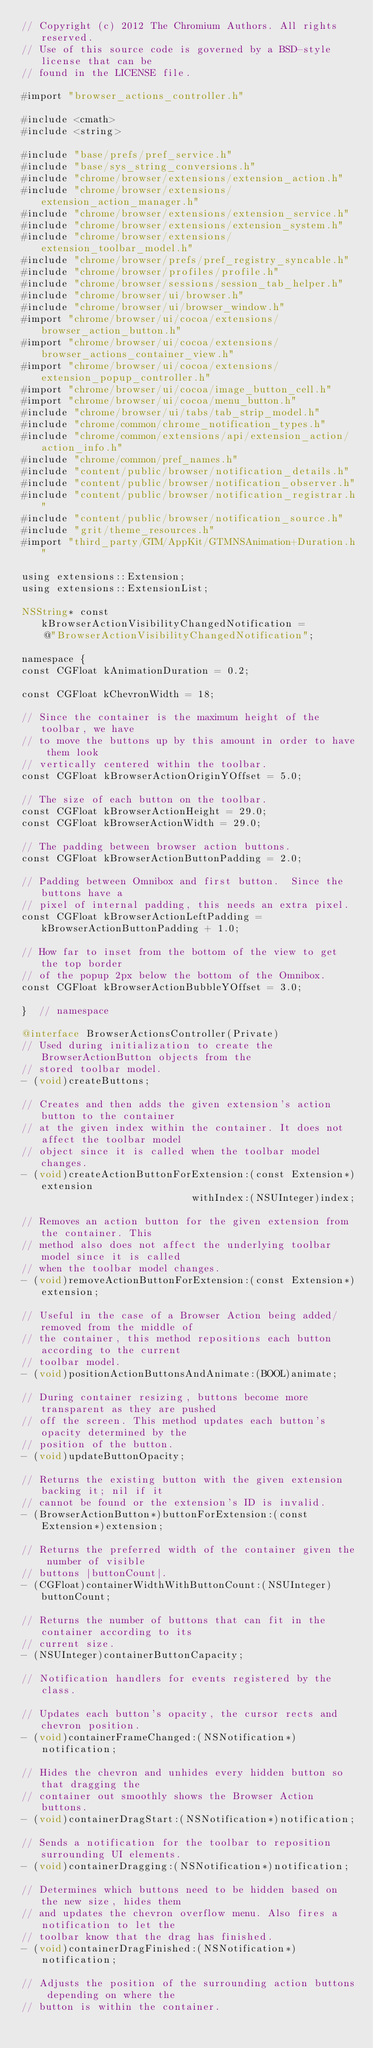<code> <loc_0><loc_0><loc_500><loc_500><_ObjectiveC_>// Copyright (c) 2012 The Chromium Authors. All rights reserved.
// Use of this source code is governed by a BSD-style license that can be
// found in the LICENSE file.

#import "browser_actions_controller.h"

#include <cmath>
#include <string>

#include "base/prefs/pref_service.h"
#include "base/sys_string_conversions.h"
#include "chrome/browser/extensions/extension_action.h"
#include "chrome/browser/extensions/extension_action_manager.h"
#include "chrome/browser/extensions/extension_service.h"
#include "chrome/browser/extensions/extension_system.h"
#include "chrome/browser/extensions/extension_toolbar_model.h"
#include "chrome/browser/prefs/pref_registry_syncable.h"
#include "chrome/browser/profiles/profile.h"
#include "chrome/browser/sessions/session_tab_helper.h"
#include "chrome/browser/ui/browser.h"
#include "chrome/browser/ui/browser_window.h"
#import "chrome/browser/ui/cocoa/extensions/browser_action_button.h"
#import "chrome/browser/ui/cocoa/extensions/browser_actions_container_view.h"
#import "chrome/browser/ui/cocoa/extensions/extension_popup_controller.h"
#import "chrome/browser/ui/cocoa/image_button_cell.h"
#import "chrome/browser/ui/cocoa/menu_button.h"
#include "chrome/browser/ui/tabs/tab_strip_model.h"
#include "chrome/common/chrome_notification_types.h"
#include "chrome/common/extensions/api/extension_action/action_info.h"
#include "chrome/common/pref_names.h"
#include "content/public/browser/notification_details.h"
#include "content/public/browser/notification_observer.h"
#include "content/public/browser/notification_registrar.h"
#include "content/public/browser/notification_source.h"
#include "grit/theme_resources.h"
#import "third_party/GTM/AppKit/GTMNSAnimation+Duration.h"

using extensions::Extension;
using extensions::ExtensionList;

NSString* const kBrowserActionVisibilityChangedNotification =
    @"BrowserActionVisibilityChangedNotification";

namespace {
const CGFloat kAnimationDuration = 0.2;

const CGFloat kChevronWidth = 18;

// Since the container is the maximum height of the toolbar, we have
// to move the buttons up by this amount in order to have them look
// vertically centered within the toolbar.
const CGFloat kBrowserActionOriginYOffset = 5.0;

// The size of each button on the toolbar.
const CGFloat kBrowserActionHeight = 29.0;
const CGFloat kBrowserActionWidth = 29.0;

// The padding between browser action buttons.
const CGFloat kBrowserActionButtonPadding = 2.0;

// Padding between Omnibox and first button.  Since the buttons have a
// pixel of internal padding, this needs an extra pixel.
const CGFloat kBrowserActionLeftPadding = kBrowserActionButtonPadding + 1.0;

// How far to inset from the bottom of the view to get the top border
// of the popup 2px below the bottom of the Omnibox.
const CGFloat kBrowserActionBubbleYOffset = 3.0;

}  // namespace

@interface BrowserActionsController(Private)
// Used during initialization to create the BrowserActionButton objects from the
// stored toolbar model.
- (void)createButtons;

// Creates and then adds the given extension's action button to the container
// at the given index within the container. It does not affect the toolbar model
// object since it is called when the toolbar model changes.
- (void)createActionButtonForExtension:(const Extension*)extension
                             withIndex:(NSUInteger)index;

// Removes an action button for the given extension from the container. This
// method also does not affect the underlying toolbar model since it is called
// when the toolbar model changes.
- (void)removeActionButtonForExtension:(const Extension*)extension;

// Useful in the case of a Browser Action being added/removed from the middle of
// the container, this method repositions each button according to the current
// toolbar model.
- (void)positionActionButtonsAndAnimate:(BOOL)animate;

// During container resizing, buttons become more transparent as they are pushed
// off the screen. This method updates each button's opacity determined by the
// position of the button.
- (void)updateButtonOpacity;

// Returns the existing button with the given extension backing it; nil if it
// cannot be found or the extension's ID is invalid.
- (BrowserActionButton*)buttonForExtension:(const Extension*)extension;

// Returns the preferred width of the container given the number of visible
// buttons |buttonCount|.
- (CGFloat)containerWidthWithButtonCount:(NSUInteger)buttonCount;

// Returns the number of buttons that can fit in the container according to its
// current size.
- (NSUInteger)containerButtonCapacity;

// Notification handlers for events registered by the class.

// Updates each button's opacity, the cursor rects and chevron position.
- (void)containerFrameChanged:(NSNotification*)notification;

// Hides the chevron and unhides every hidden button so that dragging the
// container out smoothly shows the Browser Action buttons.
- (void)containerDragStart:(NSNotification*)notification;

// Sends a notification for the toolbar to reposition surrounding UI elements.
- (void)containerDragging:(NSNotification*)notification;

// Determines which buttons need to be hidden based on the new size, hides them
// and updates the chevron overflow menu. Also fires a notification to let the
// toolbar know that the drag has finished.
- (void)containerDragFinished:(NSNotification*)notification;

// Adjusts the position of the surrounding action buttons depending on where the
// button is within the container.</code> 